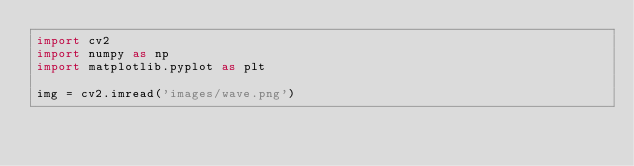<code> <loc_0><loc_0><loc_500><loc_500><_Python_>import cv2
import numpy as np 
import matplotlib.pyplot as plt 

img = cv2.imread('images/wave.png')</code> 